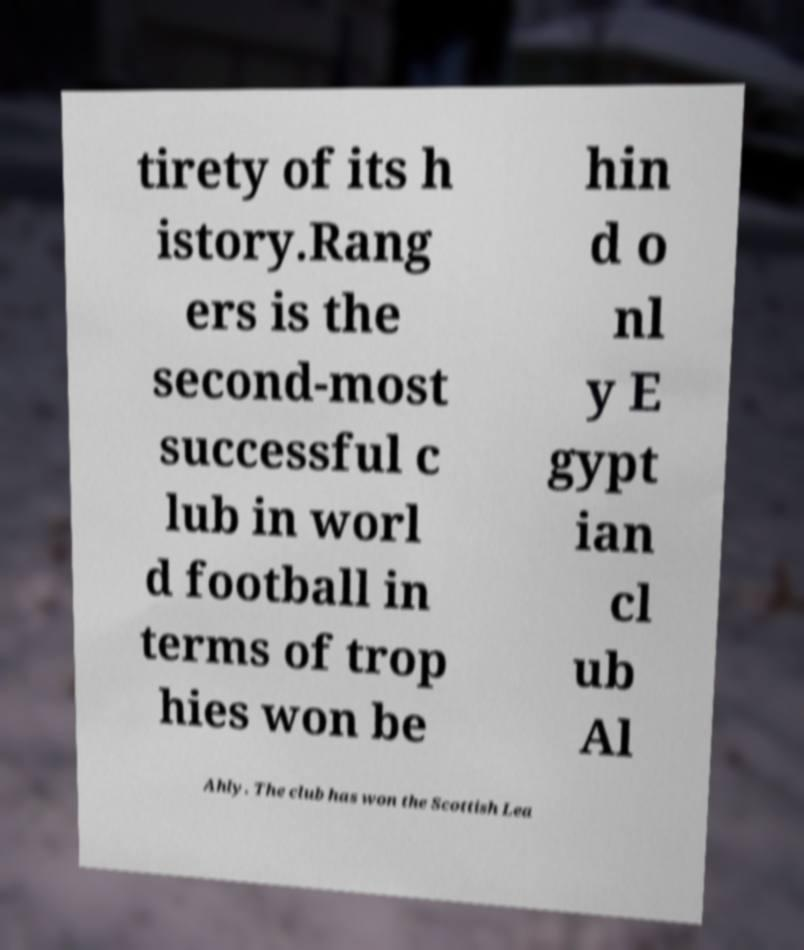For documentation purposes, I need the text within this image transcribed. Could you provide that? tirety of its h istory.Rang ers is the second-most successful c lub in worl d football in terms of trop hies won be hin d o nl y E gypt ian cl ub Al Ahly. The club has won the Scottish Lea 